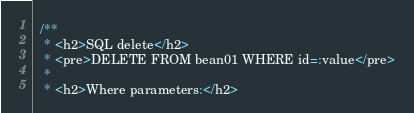Convert code to text. <code><loc_0><loc_0><loc_500><loc_500><_Java_>  /**
   * <h2>SQL delete</h2>
   * <pre>DELETE FROM bean01 WHERE id=:value</pre>
   *
   * <h2>Where parameters:</h2></code> 